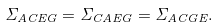Convert formula to latex. <formula><loc_0><loc_0><loc_500><loc_500>\Sigma _ { A C E G } = \Sigma _ { C A E G } = \Sigma _ { A C G E } .</formula> 